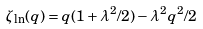<formula> <loc_0><loc_0><loc_500><loc_500>\zeta _ { \ln } ( q ) = q ( 1 + \lambda ^ { 2 } / 2 ) - \lambda ^ { 2 } q ^ { 2 } / 2</formula> 